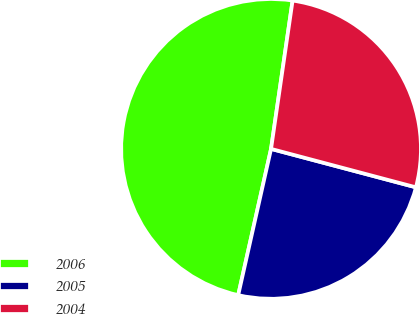<chart> <loc_0><loc_0><loc_500><loc_500><pie_chart><fcel>2006<fcel>2005<fcel>2004<nl><fcel>48.78%<fcel>24.39%<fcel>26.83%<nl></chart> 